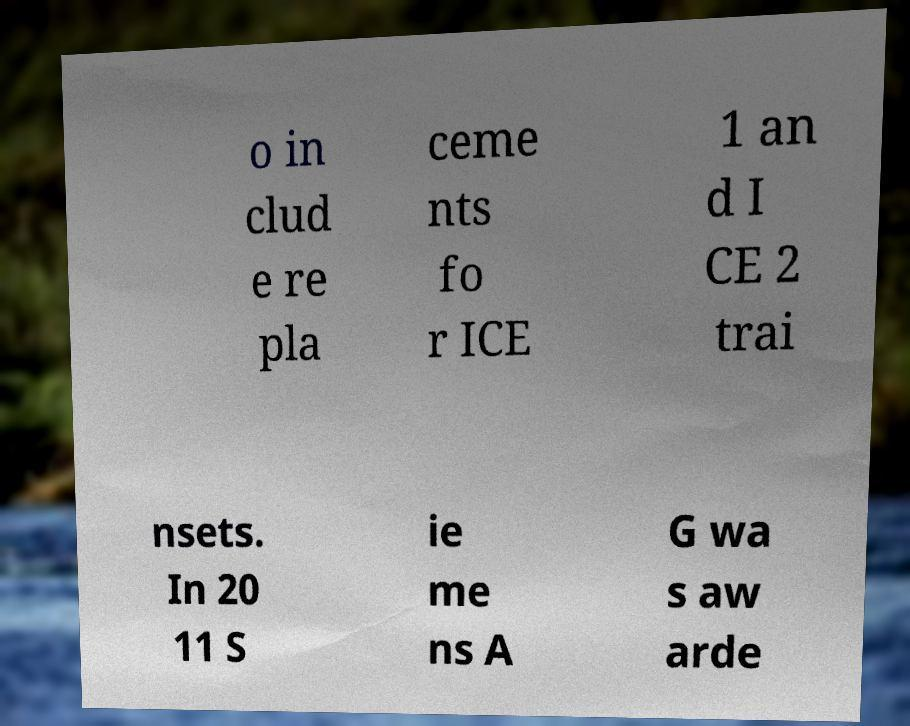Can you accurately transcribe the text from the provided image for me? o in clud e re pla ceme nts fo r ICE 1 an d I CE 2 trai nsets. In 20 11 S ie me ns A G wa s aw arde 